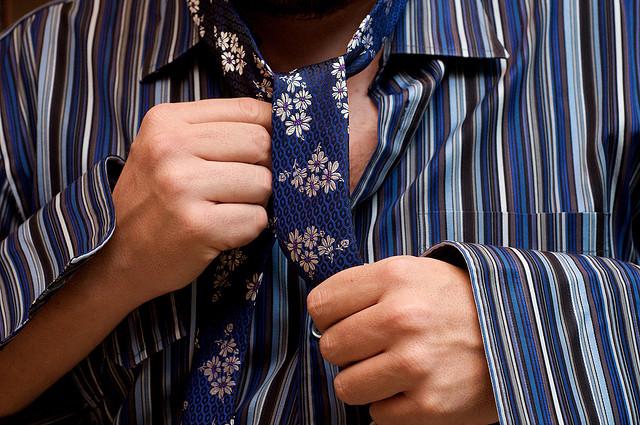Is this person about to attend a conservative gathering?
Give a very brief answer. No. How many people are in the photo?
Answer briefly. 1. Is this person married?
Quick response, please. No. 